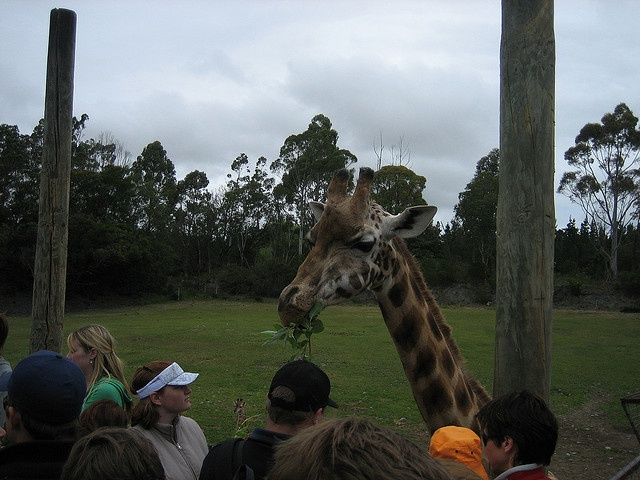Describe the objects in this image and their specific colors. I can see giraffe in lightgray, black, and gray tones, people in lightgray, black, navy, gray, and maroon tones, people in lightgray, black, and gray tones, people in lightgray, black, and darkgreen tones, and people in lightgray, black, gray, and darkgray tones in this image. 